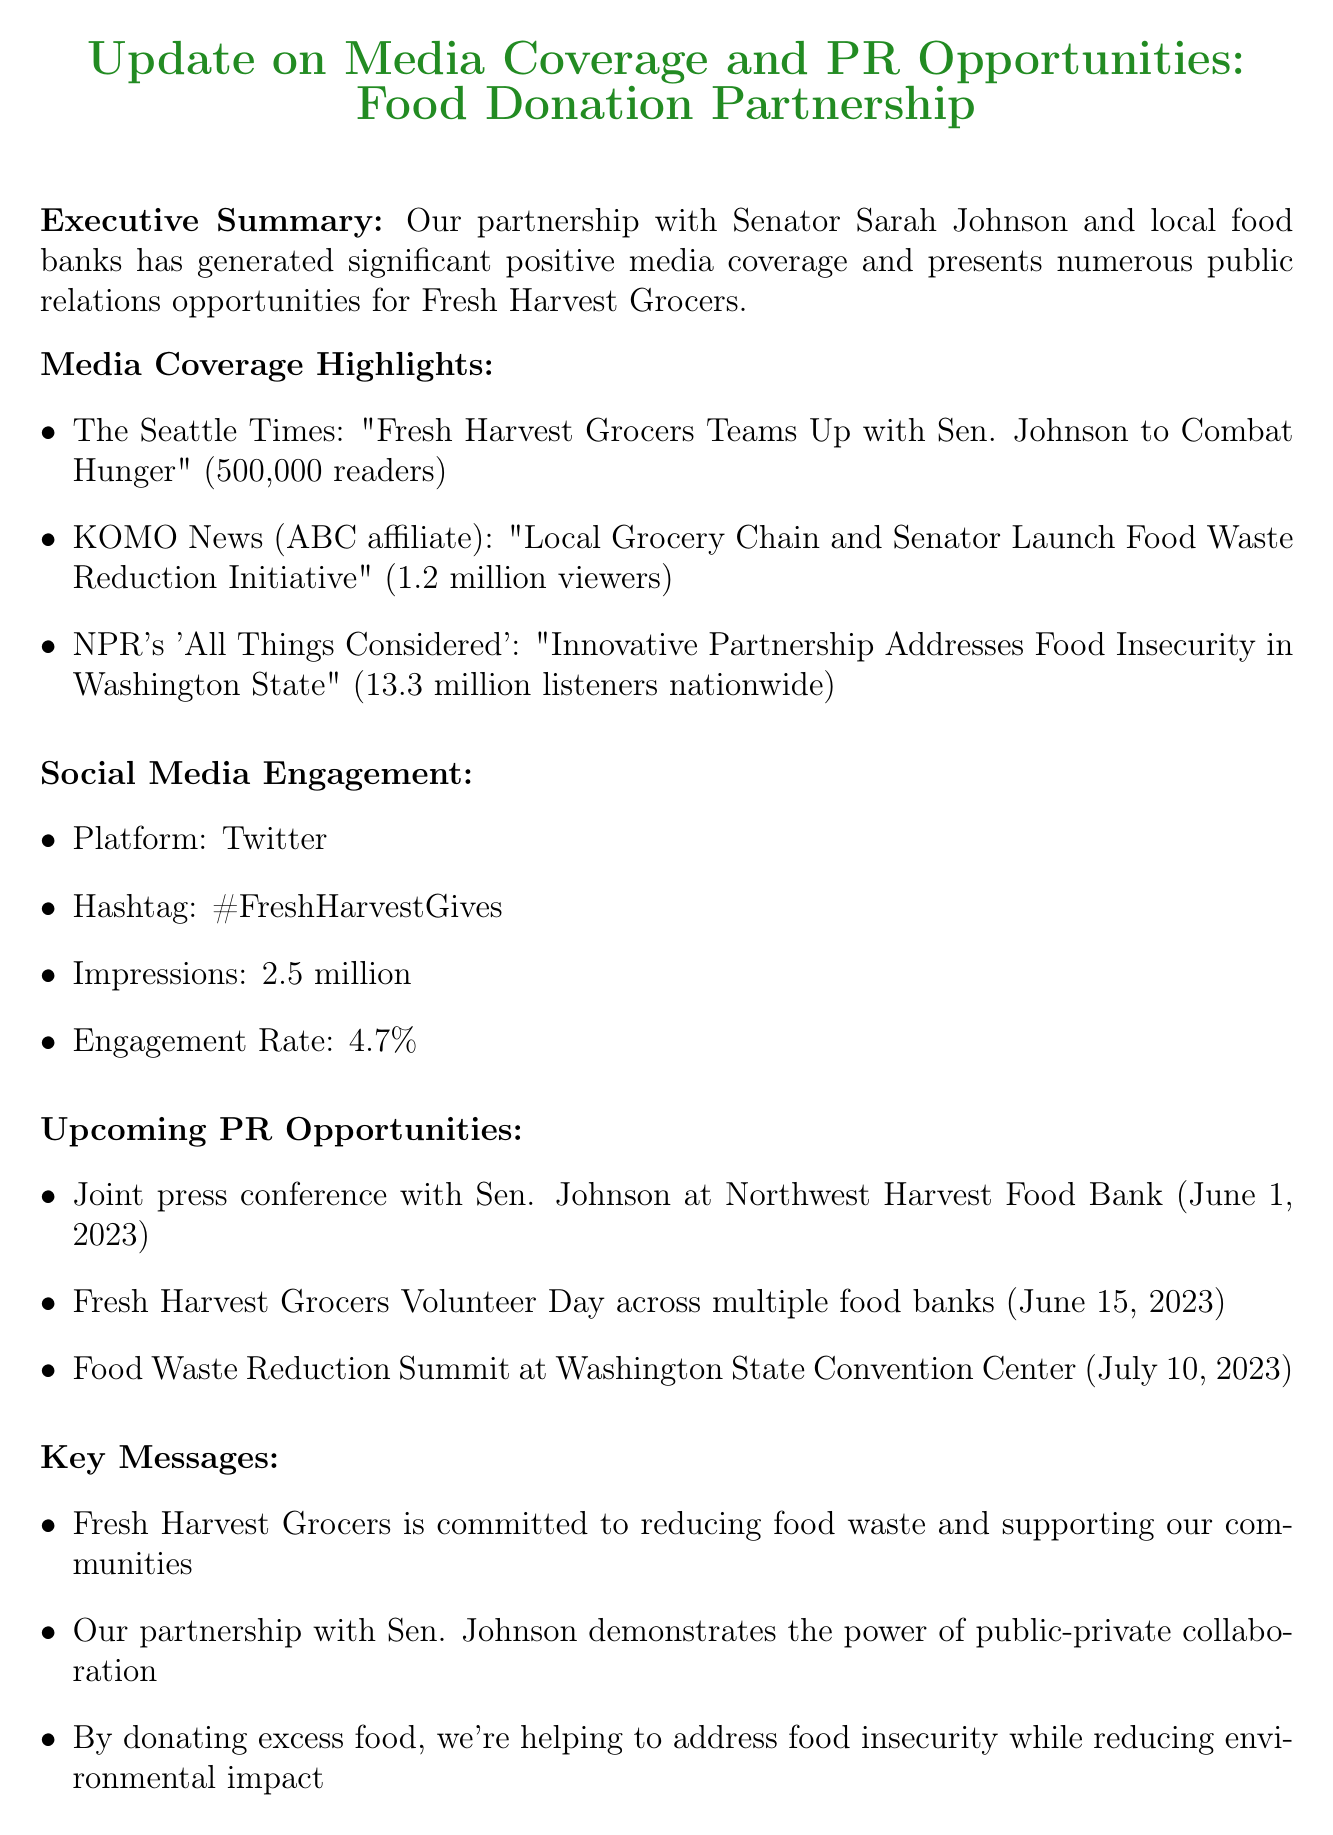What is the title of the memo? The title of the memo is the first line mentioned in the document.
Answer: Update on Media Coverage and PR Opportunities: Food Donation Partnership Who is the Senator involved in the partnership? The Senator mentioned in the partnership section of the document is referred to by name.
Answer: Senator Sarah Johnson What is the date of the joint press conference? The document lists the date of the joint press conference scheduled with Sen. Johnson.
Answer: June 1, 2023 How many impressions were recorded on Twitter? The document presents the number of impressions on Twitter as part of the social media engagement section.
Answer: 2.5 million What is the projected increase in customer loyalty? The projected increase in customer loyalty is detailed under the financial impact section of the memo.
Answer: 5% Which outlet reached 13.3 million listeners? The document specifies the media outlet and its reach in the media coverage section.
Answer: NPR's 'All Things Considered' What is one of the key messages about Fresh Harvest Grocers? The key messages section outlines important points about the grocery store's commitment and actions.
Answer: Fresh Harvest Grocers is committed to reducing food waste and supporting our communities What event is scheduled for July 10, 2023? The document outlines upcoming events, including the one scheduled for the date mentioned.
Answer: Food Waste Reduction Summit What is the estimated tax deduction from the partnership? The estimated tax deductions are provided in the financial impact section of the memo.
Answer: $500,000 